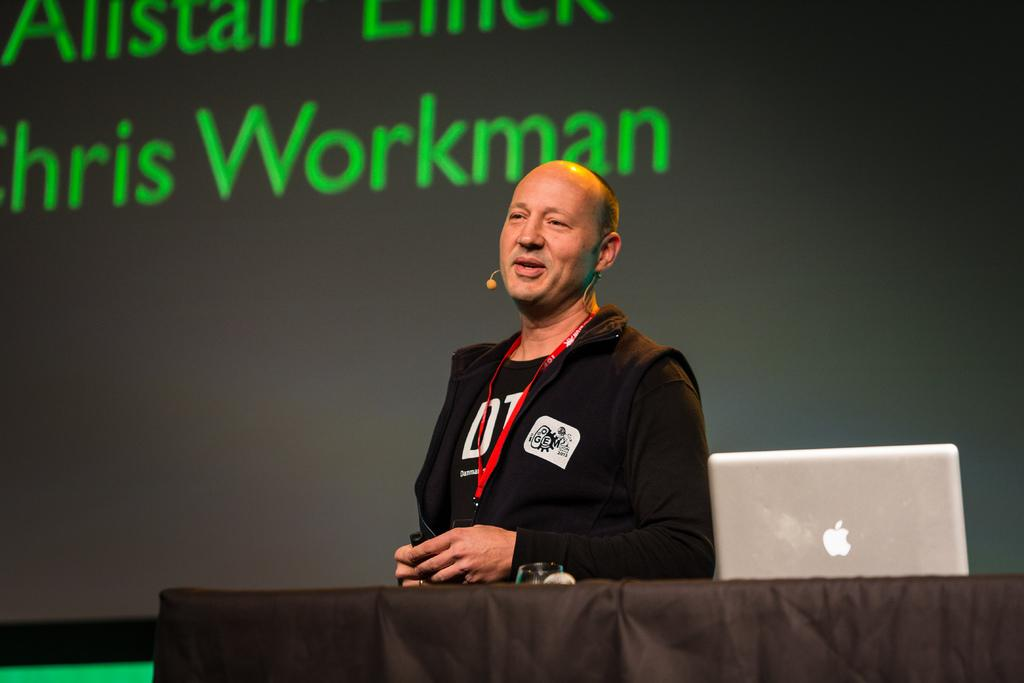<image>
Share a concise interpretation of the image provided. Man giving a speech in front of a screen that says "Workman". 